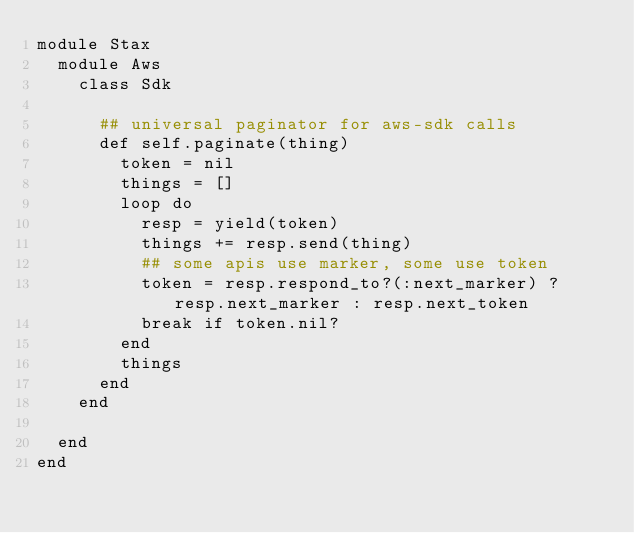<code> <loc_0><loc_0><loc_500><loc_500><_Ruby_>module Stax
  module Aws
    class Sdk

      ## universal paginator for aws-sdk calls
      def self.paginate(thing)
        token = nil
        things = []
        loop do
          resp = yield(token)
          things += resp.send(thing)
          ## some apis use marker, some use token
          token = resp.respond_to?(:next_marker) ? resp.next_marker : resp.next_token
          break if token.nil?
        end
        things
      end
    end

  end
end</code> 